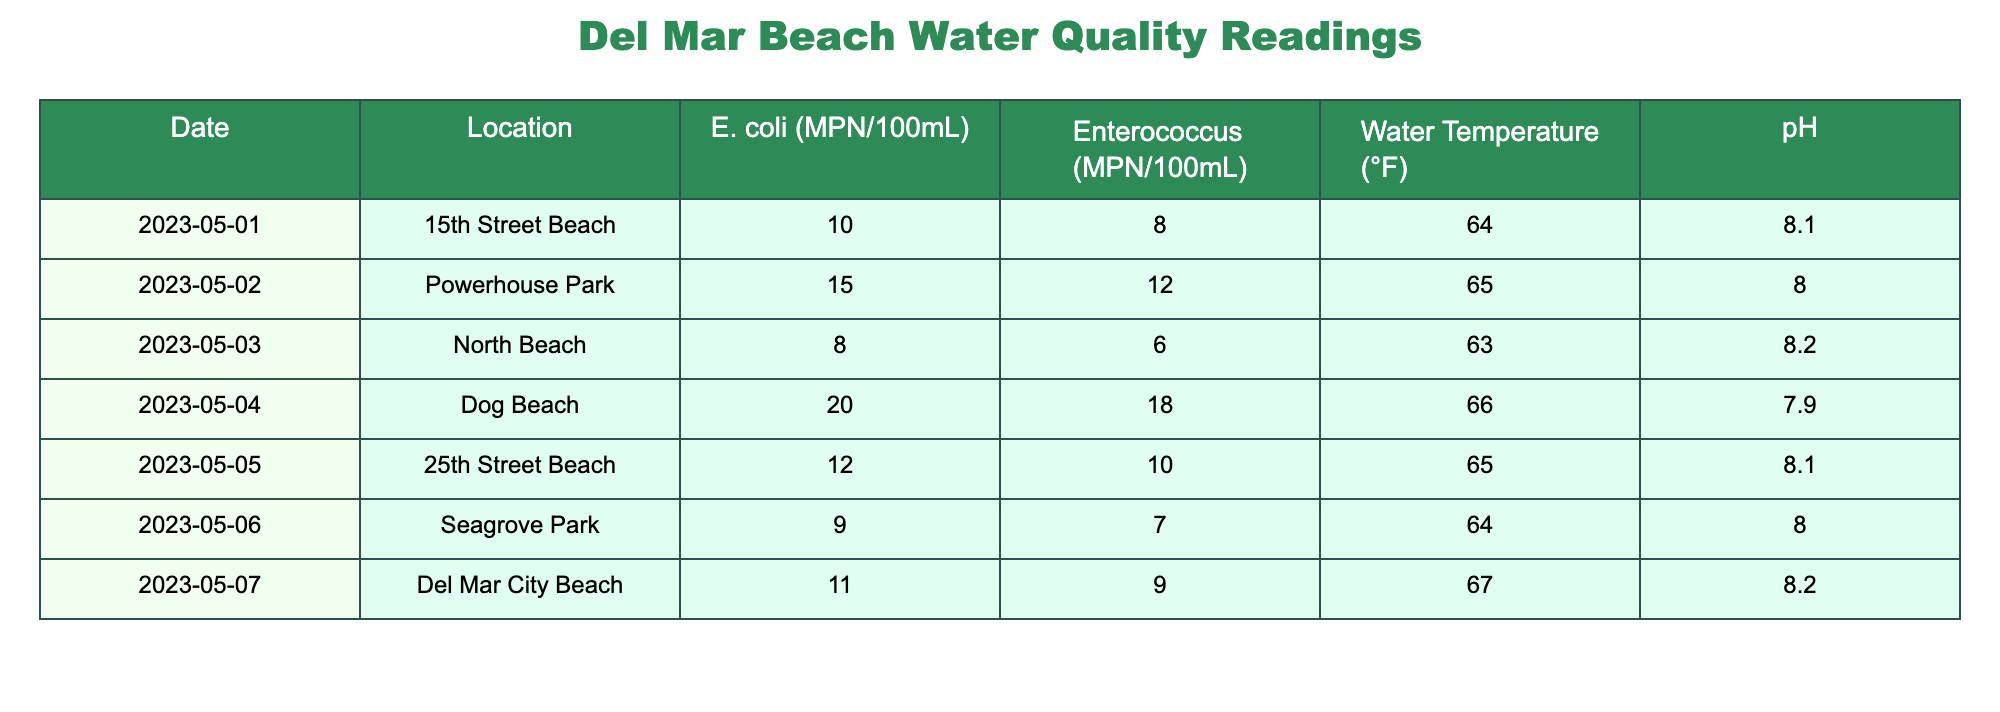What was the highest level of E. coli recorded this week? Looking through the E. coli values for each day in the table, the maximum value is 20 MPN/100mL, which was recorded on May 4 at Dog Beach.
Answer: 20 MPN/100mL Which location had the lowest Enterococcus reading? By comparing the Enterococcus values in the table, the lowest reading is 6 MPN/100mL, found at North Beach on May 3.
Answer: 6 MPN/100mL What is the average water temperature for the week? The water temperatures listed are 64, 65, 63, 66, 65, 64, and 67 degrees Fahrenheit. To calculate the average: (64 + 65 + 63 + 66 + 65 + 64 + 67) / 7 = 65 degrees Fahrenheit.
Answer: 65°F Did any day have a pH lower than 8? Checking the pH values in the table, the pH values were 8.1, 8.0, 8.2, 7.9, 8.1, 8.0, and 8.2. Since 7.9 on May 4 is indeed the only value below 8, the answer is yes.
Answer: Yes What was the difference in E. coli levels between the highest and lowest readings? The highest E. coli level is 20 MPN/100mL (Dog Beach on May 4) and the lowest is 8 MPN/100mL (North Beach on May 3). Calculating the difference: 20 - 8 = 12 MPN/100mL.
Answer: 12 MPN/100mL Which beach had the highest water temperature? Examining the water temperatures, the highest is 67°F, recorded at Del Mar City Beach on May 7.
Answer: Del Mar City Beach Were there any readings where both E. coli and Enterococcus were below 10? Checking all entries, the only day meeting this criterion is May 1 at 15th Street Beach, where E. coli is 10 and Enterococcus is 8. Since not both are under 10, the answer is no.
Answer: No What is the total E. coli count from all locations for the week? Adding all E. coli counts from the table: 10 + 15 + 8 + 20 + 12 + 9 + 11 = 85 MPN/100mL.
Answer: 85 MPN/100mL 